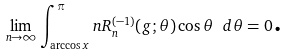Convert formula to latex. <formula><loc_0><loc_0><loc_500><loc_500>\underset { n \rightarrow \infty } { \lim } \int _ { \arccos x } ^ { \pi } n R _ { n } ^ { ( - 1 ) } ( g ; \theta ) \cos \theta \ d \theta = 0 \text {.}</formula> 